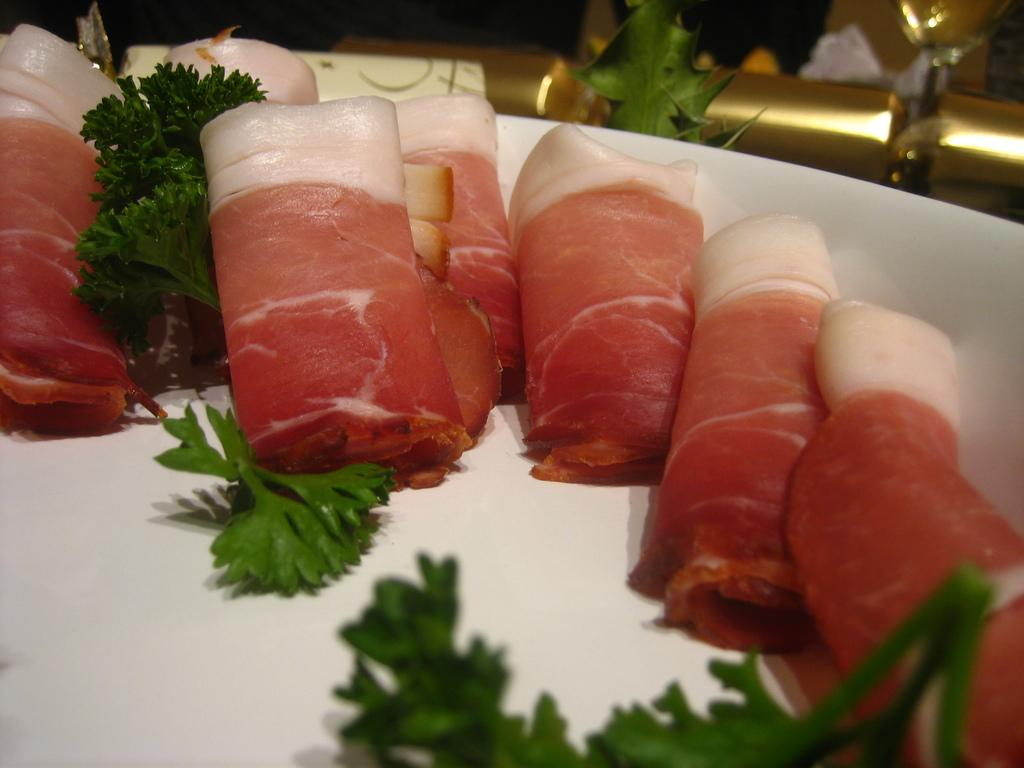What is on the plate that is visible in the image? There is a white plate in the image, and it has coriander leaves and food items on it. What type of herb is on the plate? The herb on the plate is coriander leaves. What else is on the plate besides the coriander leaves? There are food items on the plate. What can be seen behind the plate in the image? There are other things visible behind the plate in the image. What type of island is visible in the image? There is no island present in the image; it features a white plate with coriander leaves and food items. What act is being performed by the coriander leaves in the image? The coriander leaves are not performing any act in the image; they are simply placed on the plate. 